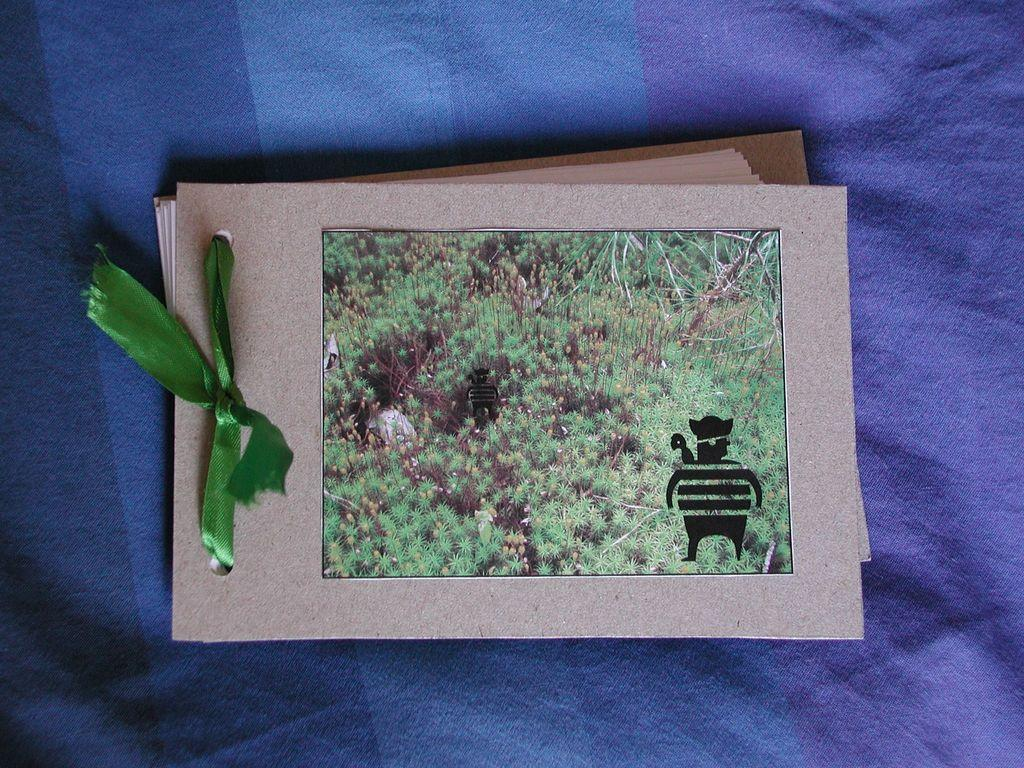What is the main object in the image? There is a book in the image. What is the book placed on? The book is on a blue cloth. What can be seen inside the book? The book contains an image of a group of plants. Is there anything else attached to the book? Yes, there is a blue object attached to the book. Can you tell me how many basketballs are visible in the image? There are no basketballs present in the image. Is there a hole in the book that allows you to see the plants? No, there is no hole in the book; the image of the plants is contained within the book. 